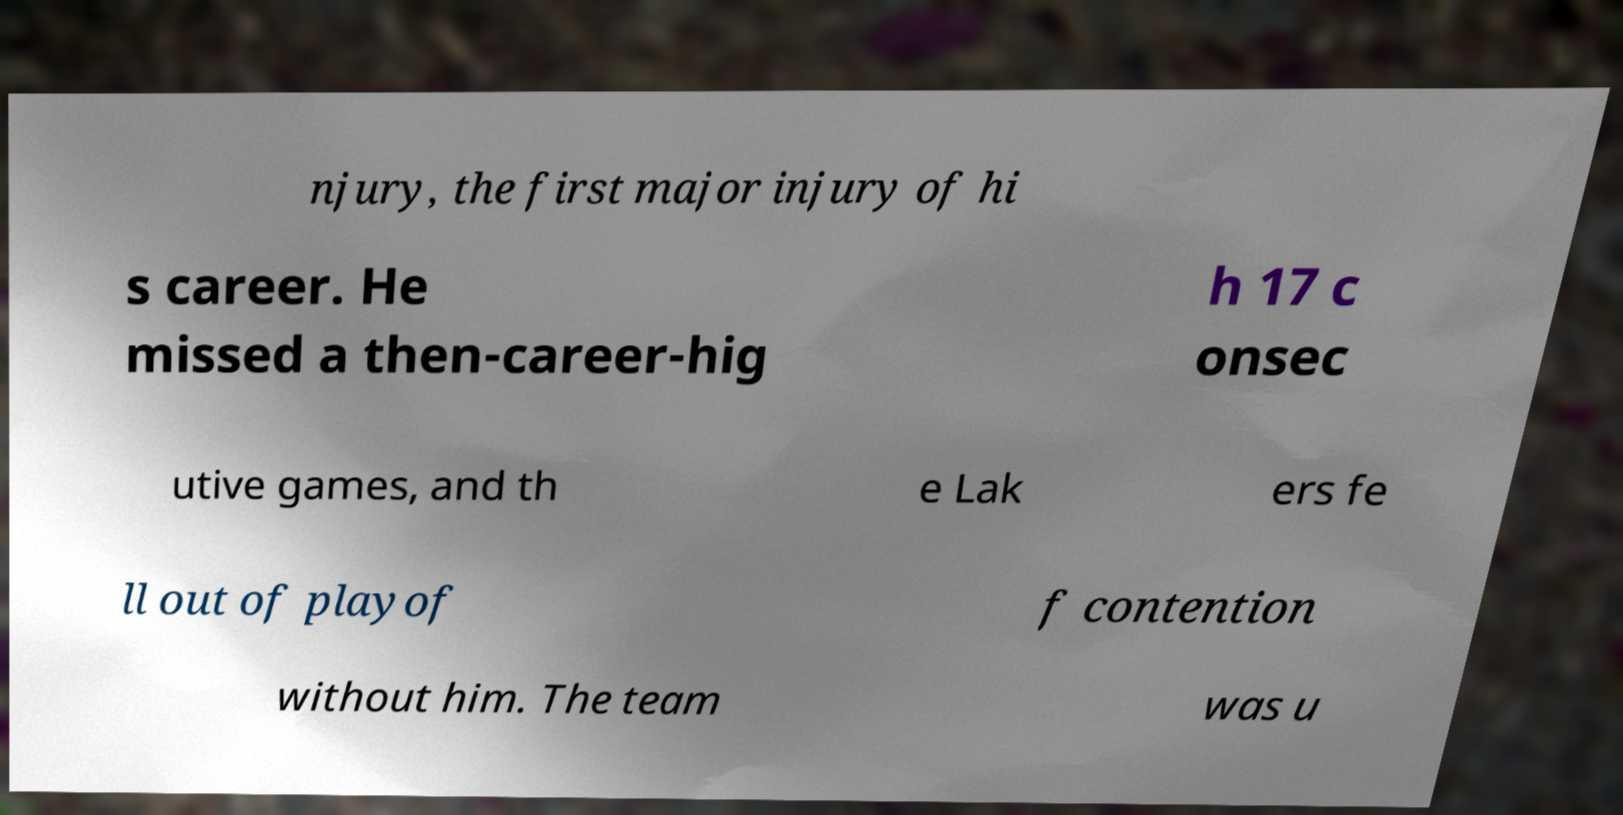Please read and relay the text visible in this image. What does it say? njury, the first major injury of hi s career. He missed a then-career-hig h 17 c onsec utive games, and th e Lak ers fe ll out of playof f contention without him. The team was u 